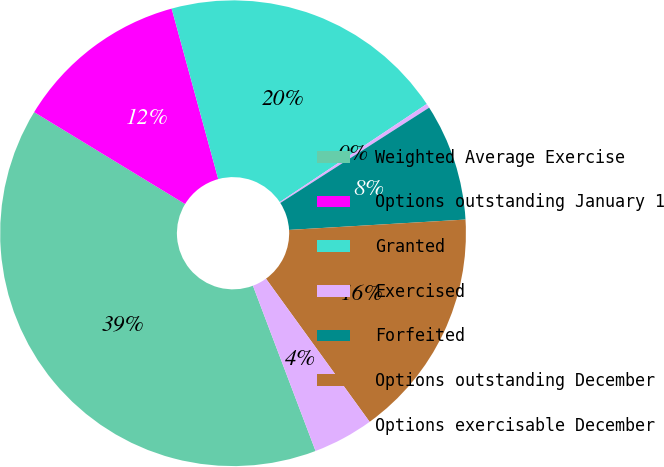<chart> <loc_0><loc_0><loc_500><loc_500><pie_chart><fcel>Weighted Average Exercise<fcel>Options outstanding January 1<fcel>Granted<fcel>Exercised<fcel>Forfeited<fcel>Options outstanding December<fcel>Options exercisable December<nl><fcel>39.47%<fcel>12.05%<fcel>19.88%<fcel>0.3%<fcel>8.13%<fcel>15.96%<fcel>4.21%<nl></chart> 